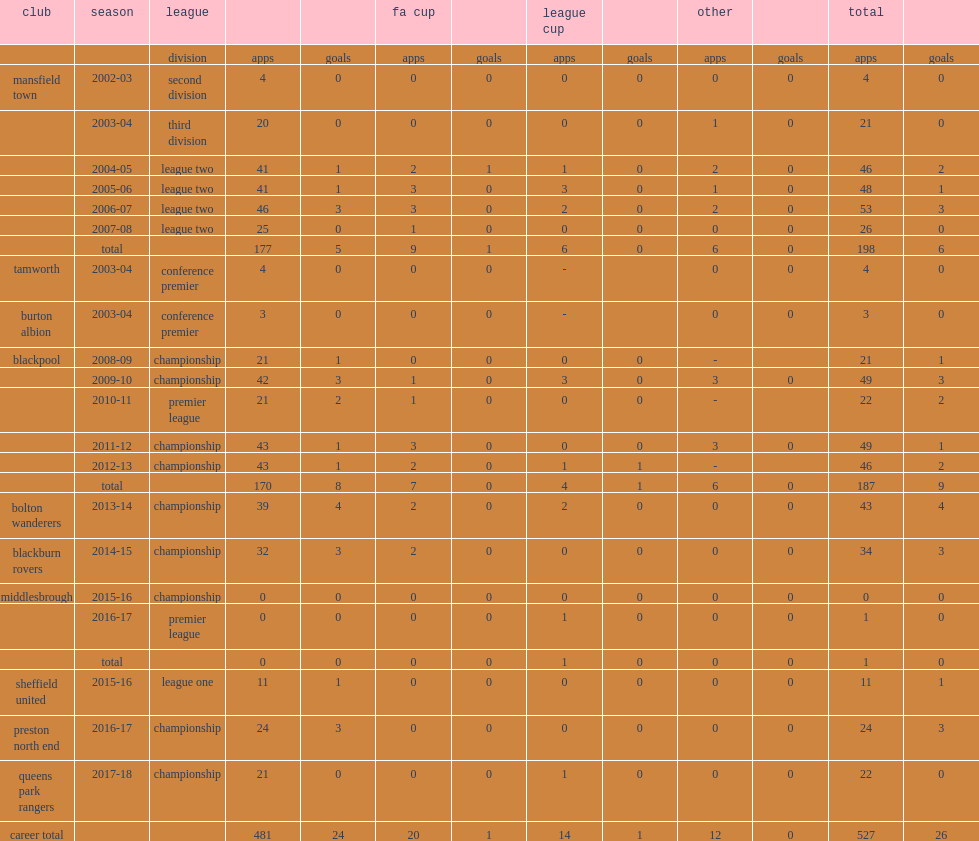Which league did alex baptiste appear for the blackpool for the 2010-11 season? Premier league. 